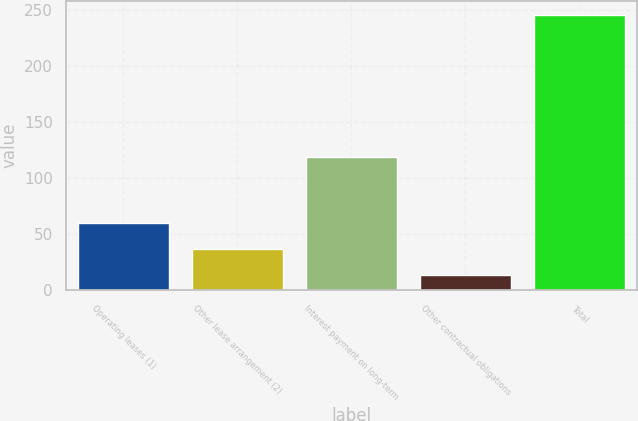Convert chart. <chart><loc_0><loc_0><loc_500><loc_500><bar_chart><fcel>Operating leases (1)<fcel>Other lease arrangement (2)<fcel>Interest payment on long-term<fcel>Other contractual obligations<fcel>Total<nl><fcel>60.38<fcel>37.19<fcel>118.7<fcel>14<fcel>245.9<nl></chart> 